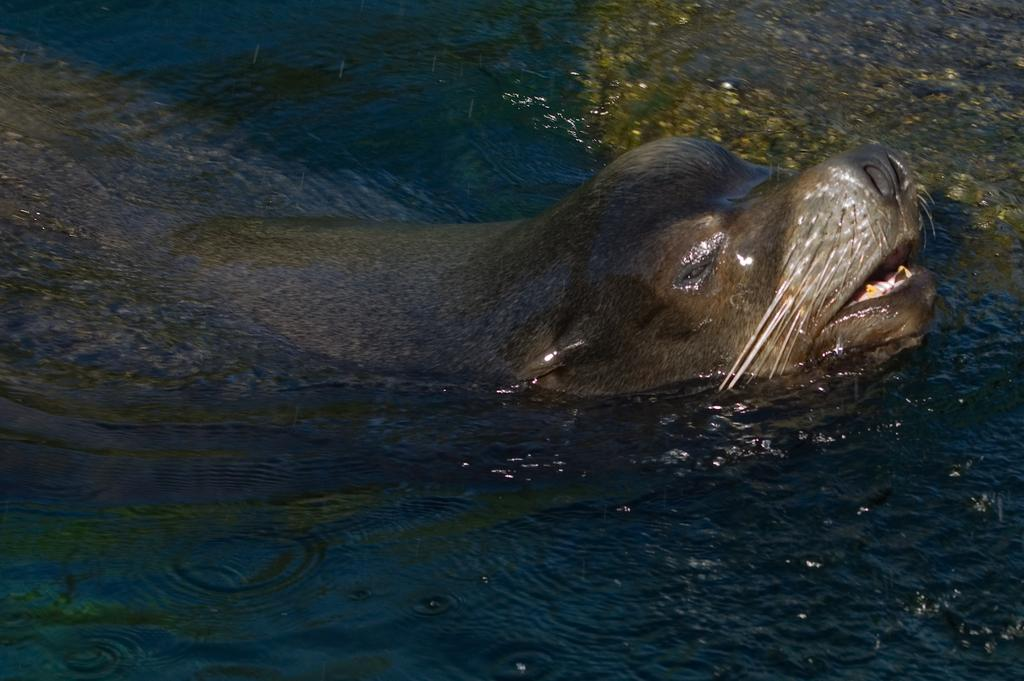What animal is in the image? There is a lion in the image. Where is the lion located? The lion is in the water. What letter is the lion holding in the image? There is no letter present in the image, as the lion is in the water and not holding any objects. 